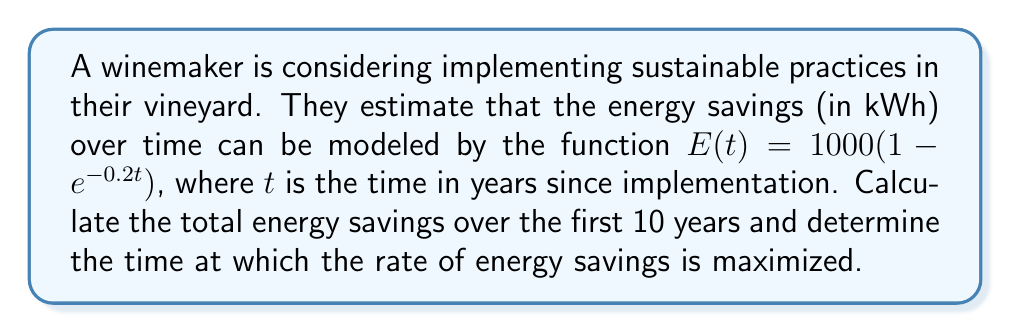Provide a solution to this math problem. 1. To calculate the total energy savings over 10 years, we need to integrate the function from 0 to 10:

   $$\int_0^{10} E(t) dt = \int_0^{10} 1000(1 - e^{-0.2t}) dt$$

2. Integrate using substitution:
   
   $$1000 \left[t + \frac{1}{0.2}e^{-0.2t}\right]_0^{10}$$

3. Evaluate the integral:
   
   $$1000 \left[(10 + \frac{1}{0.2}e^{-2}) - (0 + \frac{1}{0.2})\right]$$
   $$= 1000 \left[10 + 5e^{-2} - 5\right]$$
   $$\approx 8647.45 \text{ kWh}$$

4. To find the time when the rate of energy savings is maximized, we need to find the maximum of the derivative $E'(t)$:

   $$E'(t) = 1000 \cdot 0.2e^{-0.2t}$$

5. Set the second derivative to zero:

   $$E''(t) = 1000 \cdot (-0.2)^2e^{-0.2t} = 0$$

6. This equation is always positive for finite $t$, meaning $E'(t)$ is always decreasing. Therefore, the maximum rate occurs at $t = 0$:

   $$E'(0) = 1000 \cdot 0.2 = 200 \text{ kWh/year}$$
Answer: Total energy savings: 8647.45 kWh. Maximum rate occurs at t = 0 years, with 200 kWh/year. 